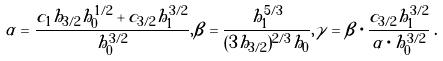Convert formula to latex. <formula><loc_0><loc_0><loc_500><loc_500>\alpha = \frac { c _ { 1 } h _ { 3 / 2 } h _ { 0 } ^ { 1 / 2 } + c _ { 3 / 2 } h _ { 1 } ^ { 3 / 2 } } { h _ { 0 } ^ { 3 / 2 } } , \beta = \frac { h _ { 1 } ^ { 5 / 3 } } { ( 3 h _ { 3 / 2 } ) ^ { 2 / 3 } h _ { 0 } } , \gamma = \beta \cdot \frac { c _ { 3 / 2 } h _ { 1 } ^ { 3 / 2 } } { \alpha \cdot h _ { 0 } ^ { 3 / 2 } } \, .</formula> 